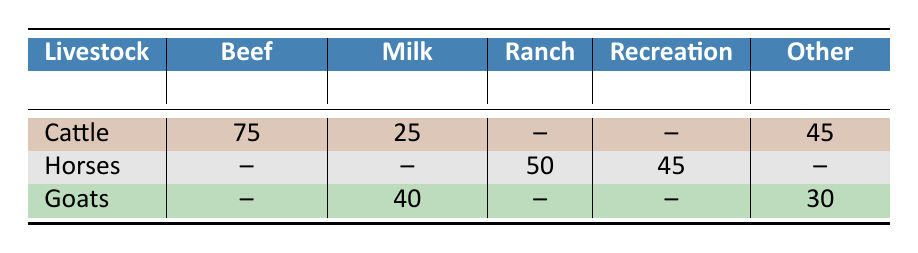What is the total number of cattle used for beef production? The table shows that 75 cattle are used for beef production.
Answer: 75 How many goats are involved in milk production? According to the table, there are 40 goats involved in milk production.
Answer: 40 Is there any cattle involved in recreational activities? The table indicates that cattle are not involved in recreational activities, as the column for recreation shows "--".
Answer: No How many horses are engaged in ranch work and recreational riding combined? For ranch work, there are 50 horses, and for recreational riding, there are 30 horses. Adding these gives 50 + 30 = 80.
Answer: 80 What is the total number of livestock involved in meat production? The table shows 20 goats involved in meat production. Cattle and horses are not involved in meat production, so the total is 20.
Answer: 20 Are there more cattle involved in breeding than goats in fiber production? Cattle have 40 involved in breeding, while goats have 10 involved in fiber production. Therefore, 40 is greater than 10.
Answer: Yes What is the difference between the number of horses in ranch work and cattle in show competitions? Horses engaged in ranch work total 50, and there are 5 cattle in show competitions. The difference is 50 - 5 = 45.
Answer: 45 How many total livestock are involved in other activities? The table shows that 45 represents training and sales for horses and 30 for goats in other activities. Summing these gives 45 + 30 = 75.
Answer: 75 What percentage of cattle is used for beef production compared to the total cattle count? The total number of cattle is 75 (beef) + 25 (milk) + 40 (breeding) + 5 (show) = 145. The percentage for beef production is (75/145) * 100 = approximately 51.72%.
Answer: 51.72% 